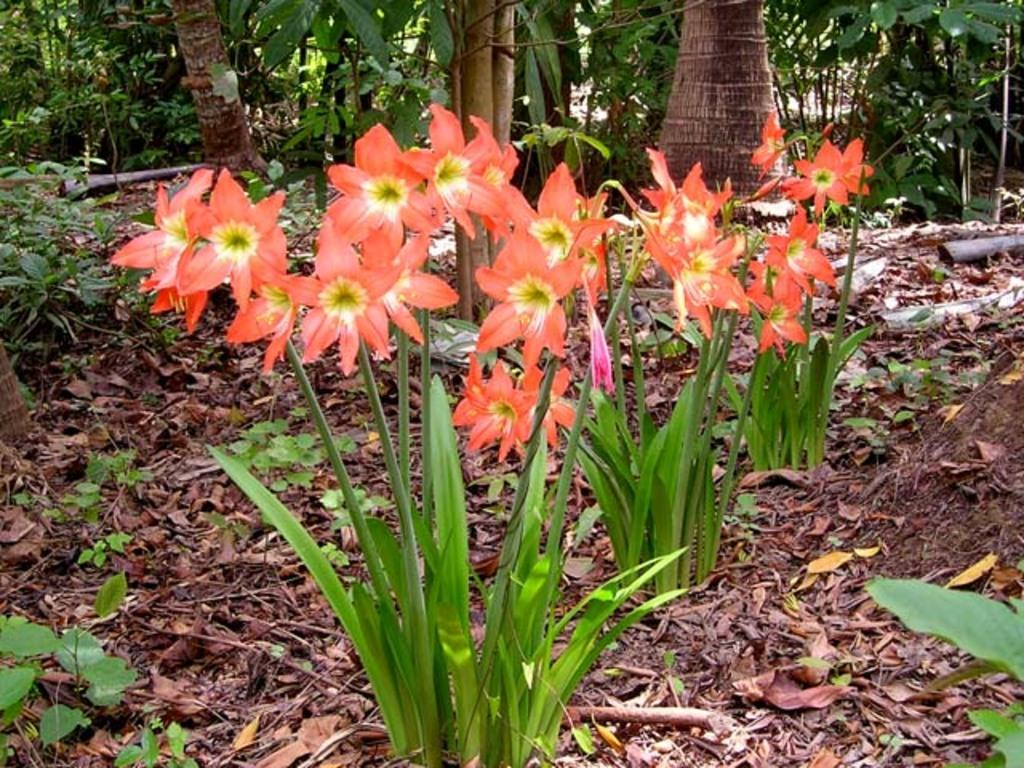What type of vegetation can be seen in the image? There are flowers on plants, trees, and other plants visible in the image. What is the condition of some of the leaves in the image? Dry leaves are visible in the image. What type of wool can be seen on the star in the image? There is no wool or star present in the image; it features plants and trees. 